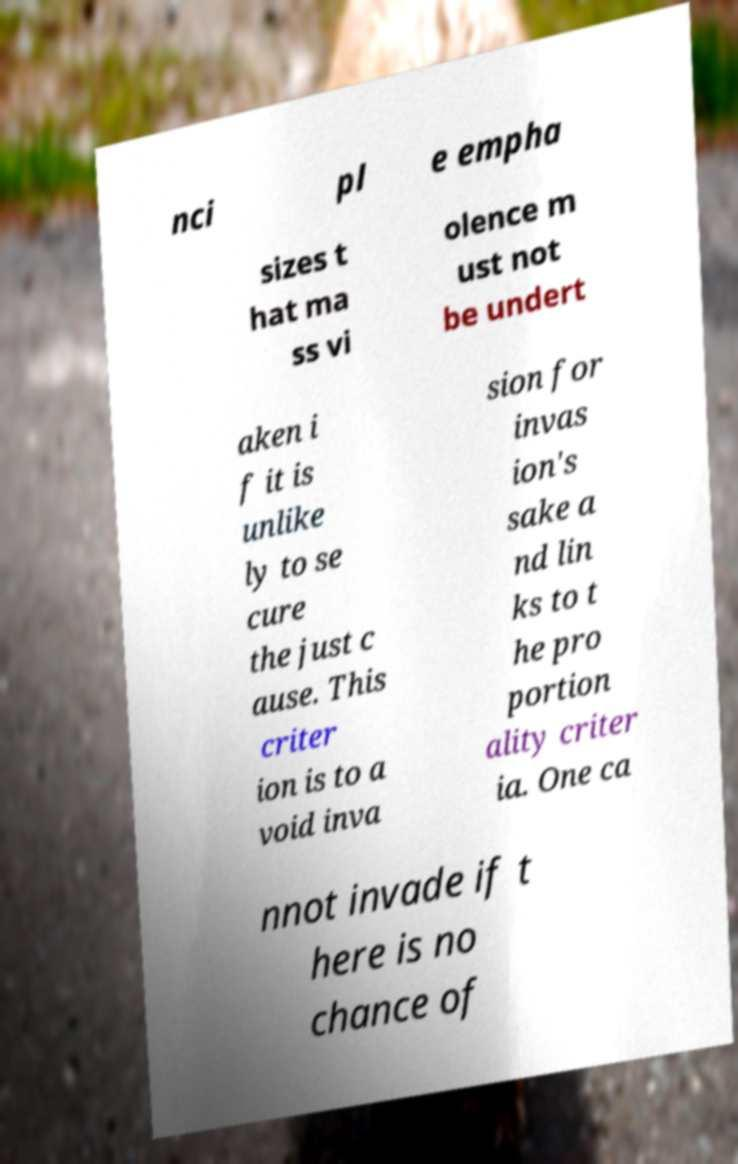Could you extract and type out the text from this image? nci pl e empha sizes t hat ma ss vi olence m ust not be undert aken i f it is unlike ly to se cure the just c ause. This criter ion is to a void inva sion for invas ion's sake a nd lin ks to t he pro portion ality criter ia. One ca nnot invade if t here is no chance of 